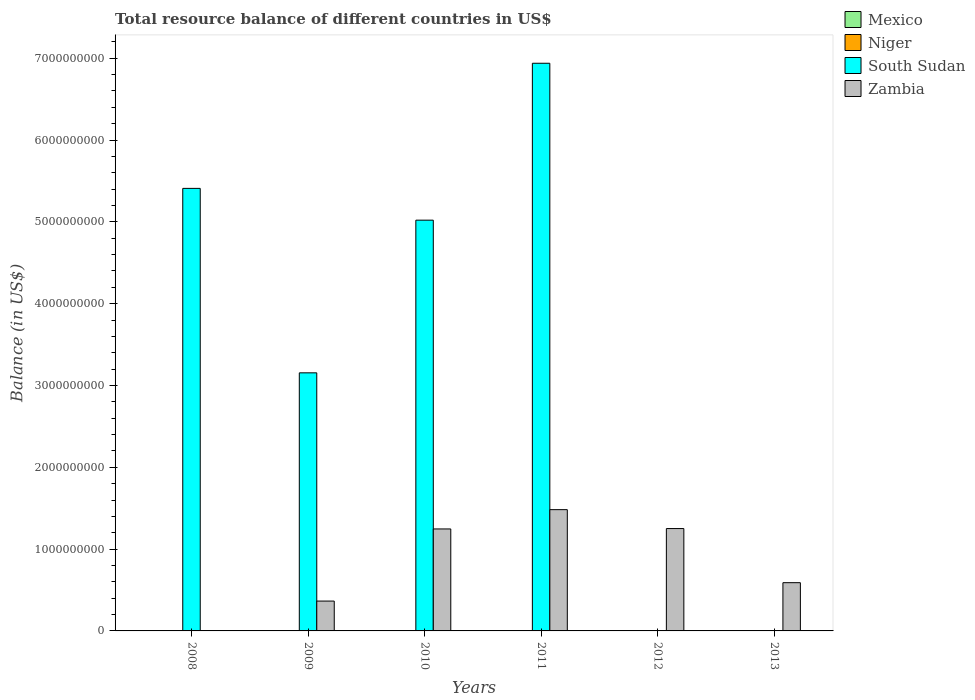Are the number of bars per tick equal to the number of legend labels?
Your response must be concise. No. How many bars are there on the 5th tick from the left?
Make the answer very short. 1. In how many cases, is the number of bars for a given year not equal to the number of legend labels?
Your answer should be compact. 6. Across all years, what is the maximum total resource balance in South Sudan?
Keep it short and to the point. 6.94e+09. Across all years, what is the minimum total resource balance in Mexico?
Provide a succinct answer. 0. What is the total total resource balance in Zambia in the graph?
Your answer should be compact. 4.94e+09. What is the difference between the total resource balance in Zambia in 2011 and that in 2012?
Keep it short and to the point. 2.31e+08. What is the difference between the total resource balance in South Sudan in 2011 and the total resource balance in Zambia in 2009?
Give a very brief answer. 6.57e+09. In the year 2009, what is the difference between the total resource balance in South Sudan and total resource balance in Zambia?
Ensure brevity in your answer.  2.79e+09. What is the ratio of the total resource balance in Zambia in 2012 to that in 2013?
Provide a succinct answer. 2.12. Is the difference between the total resource balance in South Sudan in 2009 and 2011 greater than the difference between the total resource balance in Zambia in 2009 and 2011?
Keep it short and to the point. No. What is the difference between the highest and the second highest total resource balance in Zambia?
Provide a succinct answer. 2.31e+08. What is the difference between the highest and the lowest total resource balance in Zambia?
Ensure brevity in your answer.  1.48e+09. Is the sum of the total resource balance in Zambia in 2011 and 2013 greater than the maximum total resource balance in Niger across all years?
Your answer should be very brief. Yes. Is it the case that in every year, the sum of the total resource balance in Mexico and total resource balance in South Sudan is greater than the total resource balance in Zambia?
Offer a very short reply. No. How many bars are there?
Provide a short and direct response. 9. What is the difference between two consecutive major ticks on the Y-axis?
Give a very brief answer. 1.00e+09. Does the graph contain any zero values?
Provide a succinct answer. Yes. Where does the legend appear in the graph?
Provide a succinct answer. Top right. What is the title of the graph?
Your answer should be compact. Total resource balance of different countries in US$. What is the label or title of the Y-axis?
Provide a short and direct response. Balance (in US$). What is the Balance (in US$) in South Sudan in 2008?
Keep it short and to the point. 5.41e+09. What is the Balance (in US$) of Zambia in 2008?
Keep it short and to the point. 0. What is the Balance (in US$) of Niger in 2009?
Your answer should be very brief. 0. What is the Balance (in US$) of South Sudan in 2009?
Your answer should be compact. 3.15e+09. What is the Balance (in US$) in Zambia in 2009?
Your response must be concise. 3.65e+08. What is the Balance (in US$) in Niger in 2010?
Make the answer very short. 0. What is the Balance (in US$) of South Sudan in 2010?
Give a very brief answer. 5.02e+09. What is the Balance (in US$) in Zambia in 2010?
Provide a short and direct response. 1.25e+09. What is the Balance (in US$) of Niger in 2011?
Make the answer very short. 0. What is the Balance (in US$) in South Sudan in 2011?
Give a very brief answer. 6.94e+09. What is the Balance (in US$) of Zambia in 2011?
Provide a succinct answer. 1.48e+09. What is the Balance (in US$) of South Sudan in 2012?
Offer a very short reply. 0. What is the Balance (in US$) of Zambia in 2012?
Ensure brevity in your answer.  1.25e+09. What is the Balance (in US$) of Mexico in 2013?
Provide a succinct answer. 0. What is the Balance (in US$) in Zambia in 2013?
Offer a terse response. 5.90e+08. Across all years, what is the maximum Balance (in US$) of South Sudan?
Keep it short and to the point. 6.94e+09. Across all years, what is the maximum Balance (in US$) in Zambia?
Keep it short and to the point. 1.48e+09. Across all years, what is the minimum Balance (in US$) of South Sudan?
Keep it short and to the point. 0. Across all years, what is the minimum Balance (in US$) of Zambia?
Offer a very short reply. 0. What is the total Balance (in US$) of Mexico in the graph?
Make the answer very short. 0. What is the total Balance (in US$) in Niger in the graph?
Your response must be concise. 0. What is the total Balance (in US$) of South Sudan in the graph?
Keep it short and to the point. 2.05e+1. What is the total Balance (in US$) in Zambia in the graph?
Your response must be concise. 4.94e+09. What is the difference between the Balance (in US$) of South Sudan in 2008 and that in 2009?
Ensure brevity in your answer.  2.25e+09. What is the difference between the Balance (in US$) of South Sudan in 2008 and that in 2010?
Give a very brief answer. 3.89e+08. What is the difference between the Balance (in US$) in South Sudan in 2008 and that in 2011?
Offer a terse response. -1.53e+09. What is the difference between the Balance (in US$) of South Sudan in 2009 and that in 2010?
Your response must be concise. -1.87e+09. What is the difference between the Balance (in US$) in Zambia in 2009 and that in 2010?
Your response must be concise. -8.82e+08. What is the difference between the Balance (in US$) in South Sudan in 2009 and that in 2011?
Keep it short and to the point. -3.78e+09. What is the difference between the Balance (in US$) in Zambia in 2009 and that in 2011?
Ensure brevity in your answer.  -1.12e+09. What is the difference between the Balance (in US$) of Zambia in 2009 and that in 2012?
Your response must be concise. -8.86e+08. What is the difference between the Balance (in US$) in Zambia in 2009 and that in 2013?
Make the answer very short. -2.25e+08. What is the difference between the Balance (in US$) in South Sudan in 2010 and that in 2011?
Make the answer very short. -1.92e+09. What is the difference between the Balance (in US$) in Zambia in 2010 and that in 2011?
Ensure brevity in your answer.  -2.36e+08. What is the difference between the Balance (in US$) in Zambia in 2010 and that in 2012?
Offer a very short reply. -4.88e+06. What is the difference between the Balance (in US$) of Zambia in 2010 and that in 2013?
Your response must be concise. 6.57e+08. What is the difference between the Balance (in US$) of Zambia in 2011 and that in 2012?
Provide a succinct answer. 2.31e+08. What is the difference between the Balance (in US$) in Zambia in 2011 and that in 2013?
Provide a succinct answer. 8.93e+08. What is the difference between the Balance (in US$) of Zambia in 2012 and that in 2013?
Provide a succinct answer. 6.62e+08. What is the difference between the Balance (in US$) of South Sudan in 2008 and the Balance (in US$) of Zambia in 2009?
Ensure brevity in your answer.  5.04e+09. What is the difference between the Balance (in US$) of South Sudan in 2008 and the Balance (in US$) of Zambia in 2010?
Ensure brevity in your answer.  4.16e+09. What is the difference between the Balance (in US$) in South Sudan in 2008 and the Balance (in US$) in Zambia in 2011?
Your response must be concise. 3.93e+09. What is the difference between the Balance (in US$) in South Sudan in 2008 and the Balance (in US$) in Zambia in 2012?
Keep it short and to the point. 4.16e+09. What is the difference between the Balance (in US$) in South Sudan in 2008 and the Balance (in US$) in Zambia in 2013?
Provide a succinct answer. 4.82e+09. What is the difference between the Balance (in US$) of South Sudan in 2009 and the Balance (in US$) of Zambia in 2010?
Offer a very short reply. 1.91e+09. What is the difference between the Balance (in US$) of South Sudan in 2009 and the Balance (in US$) of Zambia in 2011?
Offer a terse response. 1.67e+09. What is the difference between the Balance (in US$) in South Sudan in 2009 and the Balance (in US$) in Zambia in 2012?
Offer a very short reply. 1.90e+09. What is the difference between the Balance (in US$) of South Sudan in 2009 and the Balance (in US$) of Zambia in 2013?
Offer a very short reply. 2.57e+09. What is the difference between the Balance (in US$) of South Sudan in 2010 and the Balance (in US$) of Zambia in 2011?
Your answer should be very brief. 3.54e+09. What is the difference between the Balance (in US$) in South Sudan in 2010 and the Balance (in US$) in Zambia in 2012?
Make the answer very short. 3.77e+09. What is the difference between the Balance (in US$) in South Sudan in 2010 and the Balance (in US$) in Zambia in 2013?
Your answer should be very brief. 4.43e+09. What is the difference between the Balance (in US$) in South Sudan in 2011 and the Balance (in US$) in Zambia in 2012?
Your answer should be very brief. 5.69e+09. What is the difference between the Balance (in US$) in South Sudan in 2011 and the Balance (in US$) in Zambia in 2013?
Your answer should be very brief. 6.35e+09. What is the average Balance (in US$) of South Sudan per year?
Give a very brief answer. 3.42e+09. What is the average Balance (in US$) of Zambia per year?
Ensure brevity in your answer.  8.23e+08. In the year 2009, what is the difference between the Balance (in US$) of South Sudan and Balance (in US$) of Zambia?
Provide a short and direct response. 2.79e+09. In the year 2010, what is the difference between the Balance (in US$) in South Sudan and Balance (in US$) in Zambia?
Offer a very short reply. 3.77e+09. In the year 2011, what is the difference between the Balance (in US$) of South Sudan and Balance (in US$) of Zambia?
Offer a terse response. 5.46e+09. What is the ratio of the Balance (in US$) of South Sudan in 2008 to that in 2009?
Your answer should be very brief. 1.71. What is the ratio of the Balance (in US$) of South Sudan in 2008 to that in 2010?
Ensure brevity in your answer.  1.08. What is the ratio of the Balance (in US$) of South Sudan in 2008 to that in 2011?
Keep it short and to the point. 0.78. What is the ratio of the Balance (in US$) of South Sudan in 2009 to that in 2010?
Keep it short and to the point. 0.63. What is the ratio of the Balance (in US$) in Zambia in 2009 to that in 2010?
Provide a succinct answer. 0.29. What is the ratio of the Balance (in US$) in South Sudan in 2009 to that in 2011?
Keep it short and to the point. 0.45. What is the ratio of the Balance (in US$) of Zambia in 2009 to that in 2011?
Provide a short and direct response. 0.25. What is the ratio of the Balance (in US$) in Zambia in 2009 to that in 2012?
Ensure brevity in your answer.  0.29. What is the ratio of the Balance (in US$) in Zambia in 2009 to that in 2013?
Ensure brevity in your answer.  0.62. What is the ratio of the Balance (in US$) in South Sudan in 2010 to that in 2011?
Your answer should be very brief. 0.72. What is the ratio of the Balance (in US$) in Zambia in 2010 to that in 2011?
Keep it short and to the point. 0.84. What is the ratio of the Balance (in US$) of Zambia in 2010 to that in 2012?
Offer a terse response. 1. What is the ratio of the Balance (in US$) in Zambia in 2010 to that in 2013?
Ensure brevity in your answer.  2.11. What is the ratio of the Balance (in US$) in Zambia in 2011 to that in 2012?
Your answer should be very brief. 1.18. What is the ratio of the Balance (in US$) in Zambia in 2011 to that in 2013?
Give a very brief answer. 2.51. What is the ratio of the Balance (in US$) in Zambia in 2012 to that in 2013?
Make the answer very short. 2.12. What is the difference between the highest and the second highest Balance (in US$) in South Sudan?
Your answer should be very brief. 1.53e+09. What is the difference between the highest and the second highest Balance (in US$) in Zambia?
Give a very brief answer. 2.31e+08. What is the difference between the highest and the lowest Balance (in US$) in South Sudan?
Your answer should be very brief. 6.94e+09. What is the difference between the highest and the lowest Balance (in US$) of Zambia?
Provide a short and direct response. 1.48e+09. 